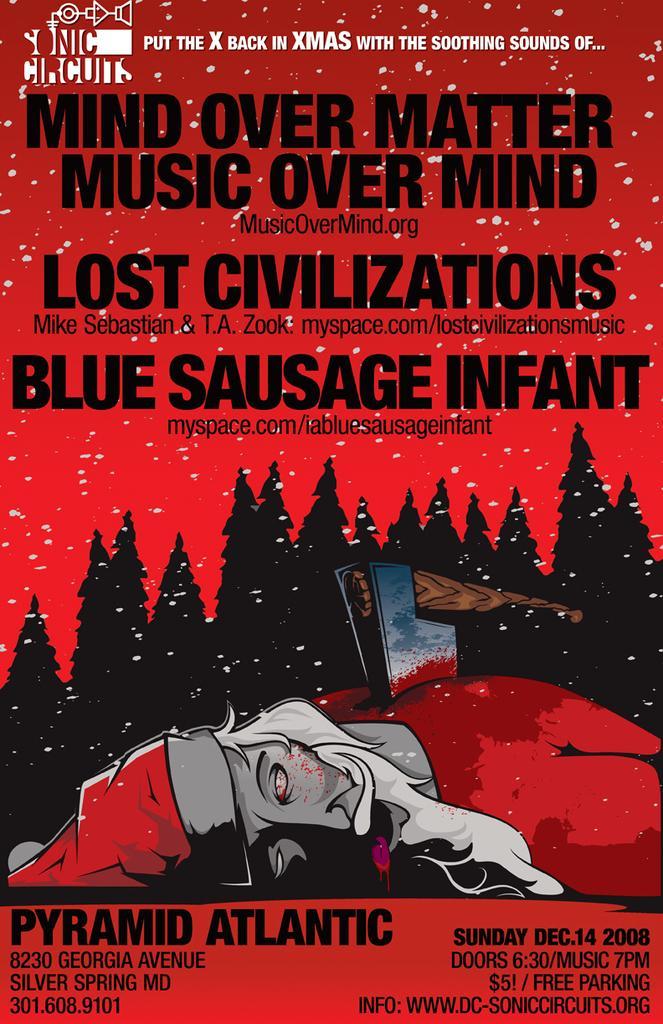Describe this image in one or two sentences. In the picture I can see one poster, on it we can see images and some text, the poster is in red in color. 